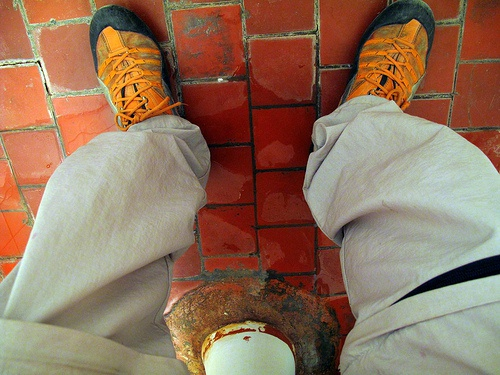Describe the objects in this image and their specific colors. I can see people in brown, darkgray, gray, and lightgray tones and toilet in brown, darkgray, beige, and maroon tones in this image. 